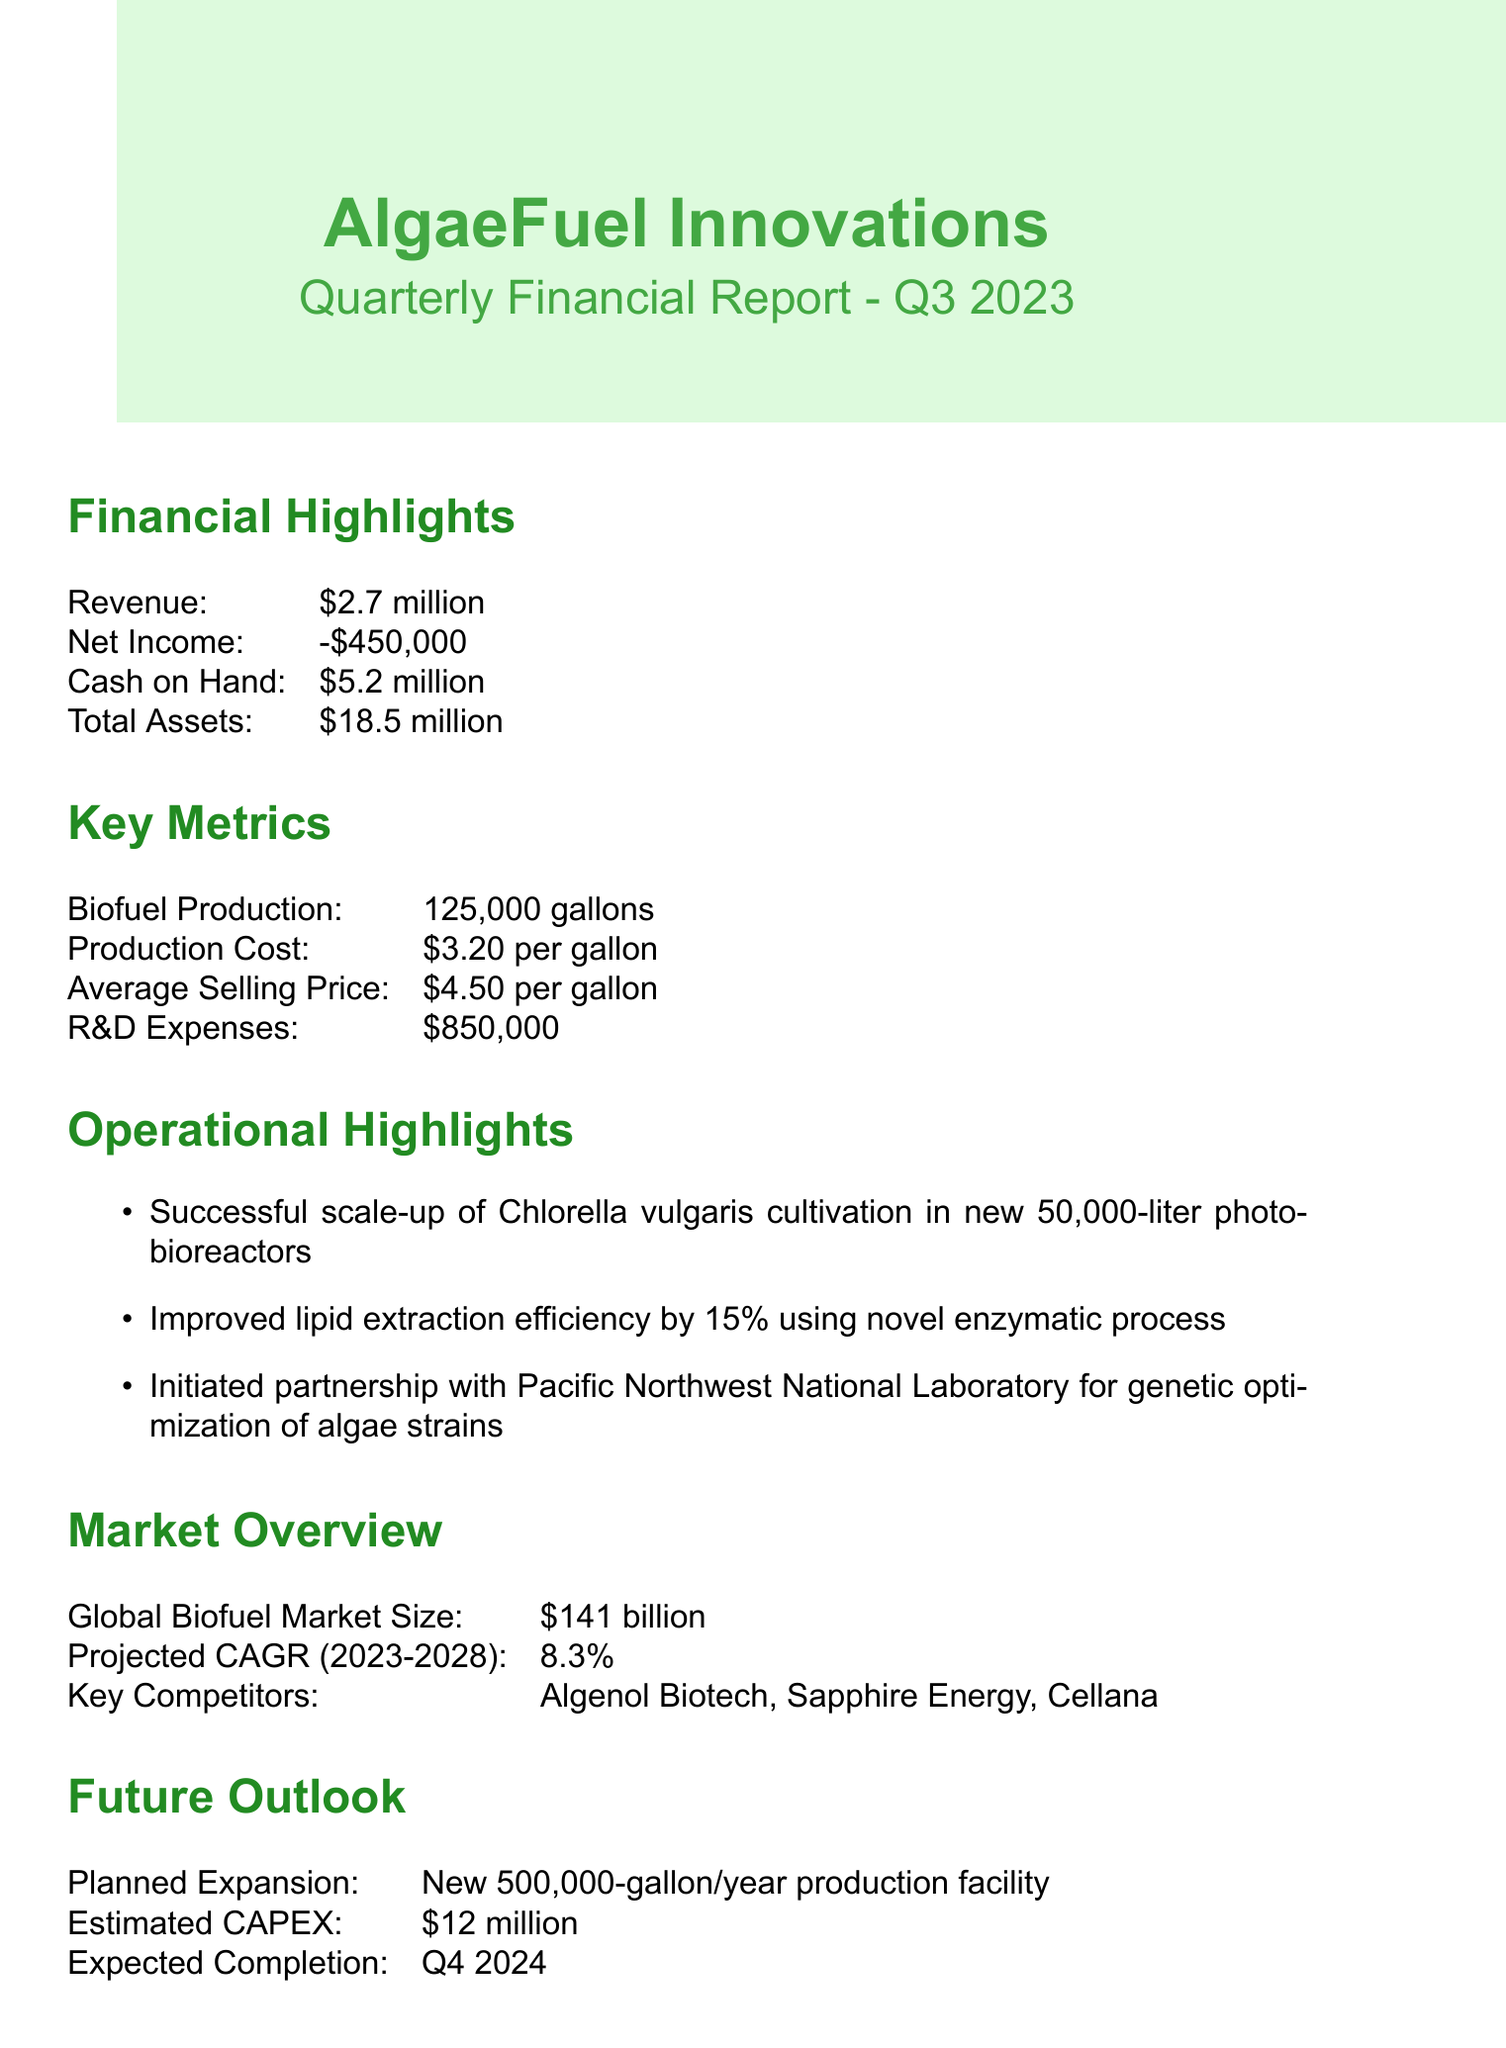what was the net income in Q3 2023? The net income can be found in the financial highlights section, listed as negative.
Answer: -$450,000 how much cash on hand does AlgaeFuel Innovations have? The cash on hand is specified in the financial highlights as part of the company's liquidity position.
Answer: $5.2 million what is the production cost per gallon of biofuel? The production cost per gallon is provided in the key metrics section of the report.
Answer: $3.20 what is the expected completion date of the new production facility? This information is mentioned in the future outlook section regarding planned expansion.
Answer: Q4 2024 how much CO2 has been sequestered by AlgaeFuel Innovations? The CO2 sequestered is listed in the sustainability impact section of the report.
Answer: 1,875 metric tons what is the estimated capital expenditure for planned expansion? The estimated capital expenditure is found in the future outlook section, which discusses financial investment for growth.
Answer: $12 million which laboratory is AlgaeFuel Innovations partnering with for genetic optimization? The partnership mentioned in the operational highlights identifies the organization involved in genetic optimization.
Answer: Pacific Northwest National Laboratory what is the average selling price per gallon for biofuel? This price is detailed in the key metrics section, indicating revenue generation from sales.
Answer: $4.50 